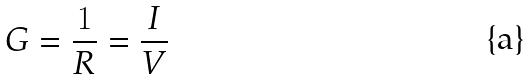Convert formula to latex. <formula><loc_0><loc_0><loc_500><loc_500>G = \frac { 1 } { R } = \frac { I } { V }</formula> 